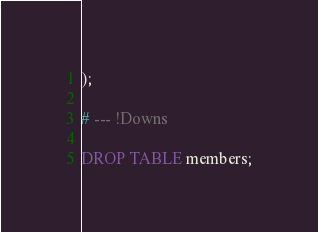<code> <loc_0><loc_0><loc_500><loc_500><_SQL_>);

# --- !Downs

DROP TABLE members;
</code> 